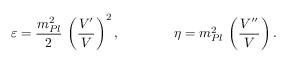Convert formula to latex. <formula><loc_0><loc_0><loc_500><loc_500>\varepsilon = { \frac { m _ { P l } ^ { 2 } } { 2 } } \, \left ( { \frac { V ^ { \prime } } { V } } \right ) ^ { 2 } , \quad \eta = m _ { P l } ^ { 2 } \, \left ( { \frac { V ^ { \prime \prime } } { V } } \right ) .</formula> 